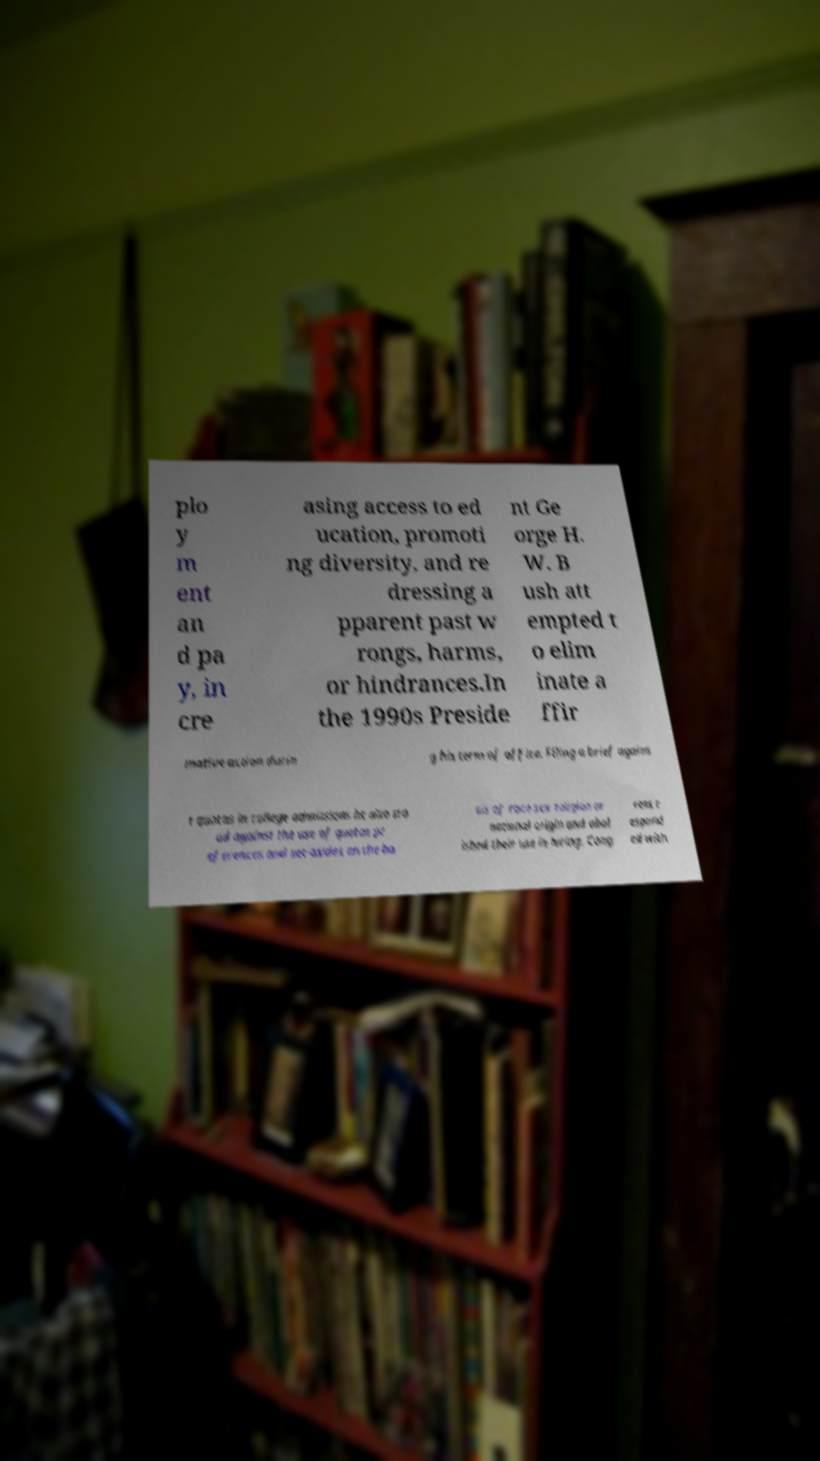There's text embedded in this image that I need extracted. Can you transcribe it verbatim? plo y m ent an d pa y, in cre asing access to ed ucation, promoti ng diversity, and re dressing a pparent past w rongs, harms, or hindrances.In the 1990s Preside nt Ge orge H. W. B ush att empted t o elim inate a ffir mative action durin g his term of office. Filing a brief agains t quotas in college admissions he also sto od against the use of quotas pr eferences and set-asides on the ba sis of race sex religion or national origin and abol ished their use in hiring. Cong ress r espond ed with 